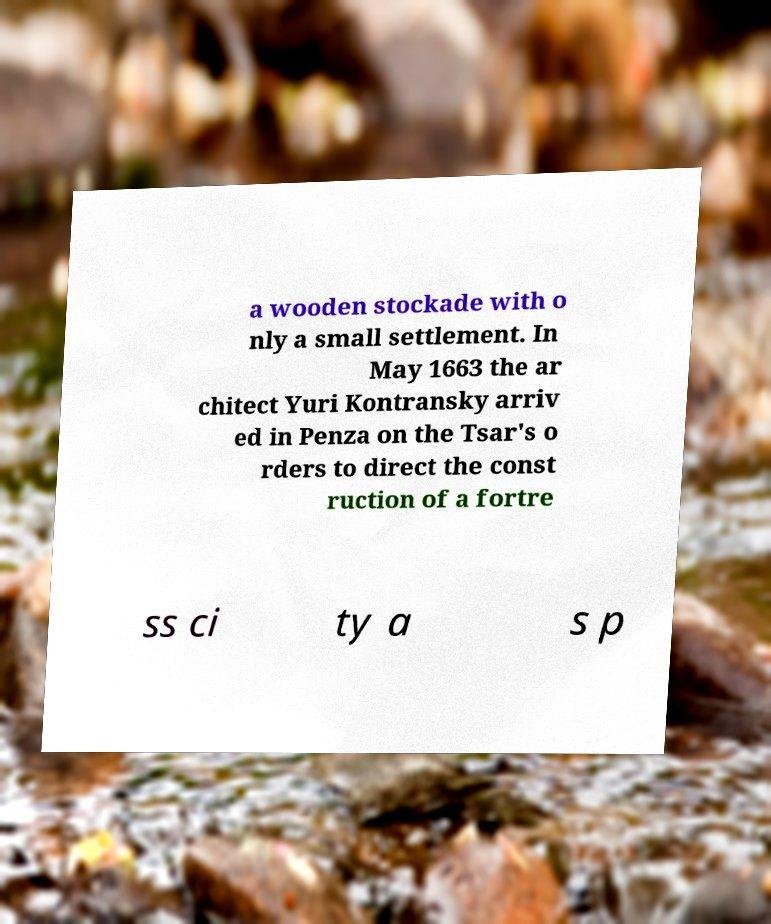Please identify and transcribe the text found in this image. a wooden stockade with o nly a small settlement. In May 1663 the ar chitect Yuri Kontransky arriv ed in Penza on the Tsar's o rders to direct the const ruction of a fortre ss ci ty a s p 